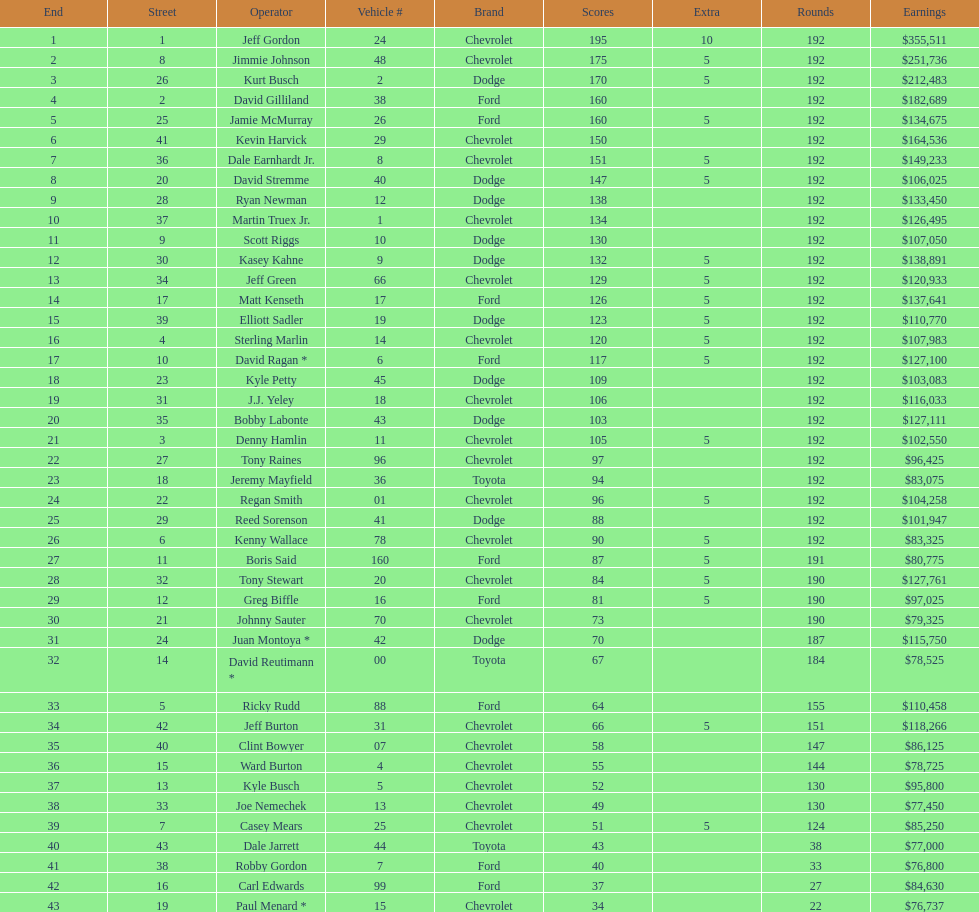How many race car drivers out of the 43 listed drove toyotas? 3. Parse the full table. {'header': ['End', 'Street', 'Operator', 'Vehicle #', 'Brand', 'Scores', 'Extra', 'Rounds', 'Earnings'], 'rows': [['1', '1', 'Jeff Gordon', '24', 'Chevrolet', '195', '10', '192', '$355,511'], ['2', '8', 'Jimmie Johnson', '48', 'Chevrolet', '175', '5', '192', '$251,736'], ['3', '26', 'Kurt Busch', '2', 'Dodge', '170', '5', '192', '$212,483'], ['4', '2', 'David Gilliland', '38', 'Ford', '160', '', '192', '$182,689'], ['5', '25', 'Jamie McMurray', '26', 'Ford', '160', '5', '192', '$134,675'], ['6', '41', 'Kevin Harvick', '29', 'Chevrolet', '150', '', '192', '$164,536'], ['7', '36', 'Dale Earnhardt Jr.', '8', 'Chevrolet', '151', '5', '192', '$149,233'], ['8', '20', 'David Stremme', '40', 'Dodge', '147', '5', '192', '$106,025'], ['9', '28', 'Ryan Newman', '12', 'Dodge', '138', '', '192', '$133,450'], ['10', '37', 'Martin Truex Jr.', '1', 'Chevrolet', '134', '', '192', '$126,495'], ['11', '9', 'Scott Riggs', '10', 'Dodge', '130', '', '192', '$107,050'], ['12', '30', 'Kasey Kahne', '9', 'Dodge', '132', '5', '192', '$138,891'], ['13', '34', 'Jeff Green', '66', 'Chevrolet', '129', '5', '192', '$120,933'], ['14', '17', 'Matt Kenseth', '17', 'Ford', '126', '5', '192', '$137,641'], ['15', '39', 'Elliott Sadler', '19', 'Dodge', '123', '5', '192', '$110,770'], ['16', '4', 'Sterling Marlin', '14', 'Chevrolet', '120', '5', '192', '$107,983'], ['17', '10', 'David Ragan *', '6', 'Ford', '117', '5', '192', '$127,100'], ['18', '23', 'Kyle Petty', '45', 'Dodge', '109', '', '192', '$103,083'], ['19', '31', 'J.J. Yeley', '18', 'Chevrolet', '106', '', '192', '$116,033'], ['20', '35', 'Bobby Labonte', '43', 'Dodge', '103', '', '192', '$127,111'], ['21', '3', 'Denny Hamlin', '11', 'Chevrolet', '105', '5', '192', '$102,550'], ['22', '27', 'Tony Raines', '96', 'Chevrolet', '97', '', '192', '$96,425'], ['23', '18', 'Jeremy Mayfield', '36', 'Toyota', '94', '', '192', '$83,075'], ['24', '22', 'Regan Smith', '01', 'Chevrolet', '96', '5', '192', '$104,258'], ['25', '29', 'Reed Sorenson', '41', 'Dodge', '88', '', '192', '$101,947'], ['26', '6', 'Kenny Wallace', '78', 'Chevrolet', '90', '5', '192', '$83,325'], ['27', '11', 'Boris Said', '160', 'Ford', '87', '5', '191', '$80,775'], ['28', '32', 'Tony Stewart', '20', 'Chevrolet', '84', '5', '190', '$127,761'], ['29', '12', 'Greg Biffle', '16', 'Ford', '81', '5', '190', '$97,025'], ['30', '21', 'Johnny Sauter', '70', 'Chevrolet', '73', '', '190', '$79,325'], ['31', '24', 'Juan Montoya *', '42', 'Dodge', '70', '', '187', '$115,750'], ['32', '14', 'David Reutimann *', '00', 'Toyota', '67', '', '184', '$78,525'], ['33', '5', 'Ricky Rudd', '88', 'Ford', '64', '', '155', '$110,458'], ['34', '42', 'Jeff Burton', '31', 'Chevrolet', '66', '5', '151', '$118,266'], ['35', '40', 'Clint Bowyer', '07', 'Chevrolet', '58', '', '147', '$86,125'], ['36', '15', 'Ward Burton', '4', 'Chevrolet', '55', '', '144', '$78,725'], ['37', '13', 'Kyle Busch', '5', 'Chevrolet', '52', '', '130', '$95,800'], ['38', '33', 'Joe Nemechek', '13', 'Chevrolet', '49', '', '130', '$77,450'], ['39', '7', 'Casey Mears', '25', 'Chevrolet', '51', '5', '124', '$85,250'], ['40', '43', 'Dale Jarrett', '44', 'Toyota', '43', '', '38', '$77,000'], ['41', '38', 'Robby Gordon', '7', 'Ford', '40', '', '33', '$76,800'], ['42', '16', 'Carl Edwards', '99', 'Ford', '37', '', '27', '$84,630'], ['43', '19', 'Paul Menard *', '15', 'Chevrolet', '34', '', '22', '$76,737']]} 